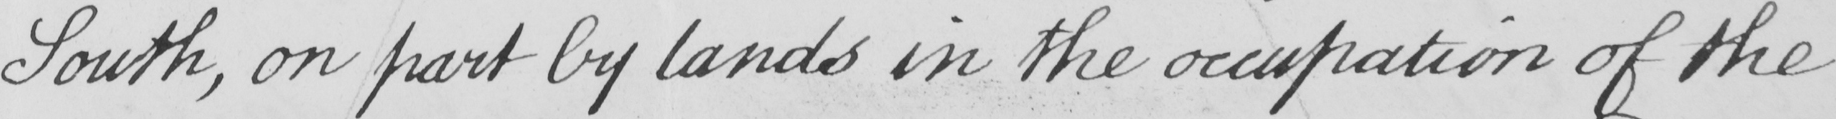What does this handwritten line say? South , on part by lands in the occupation of the 